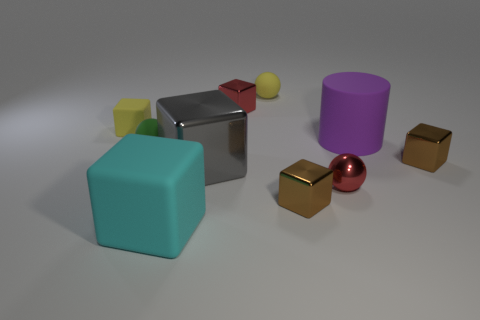Subtract 3 blocks. How many blocks are left? 3 Subtract all matte cubes. How many cubes are left? 4 Subtract all gray cubes. How many cubes are left? 5 Subtract all brown cubes. Subtract all gray spheres. How many cubes are left? 4 Subtract all spheres. How many objects are left? 7 Subtract all yellow cubes. Subtract all large blue cubes. How many objects are left? 9 Add 8 tiny brown shiny things. How many tiny brown shiny things are left? 10 Add 2 matte objects. How many matte objects exist? 7 Subtract 0 gray cylinders. How many objects are left? 10 